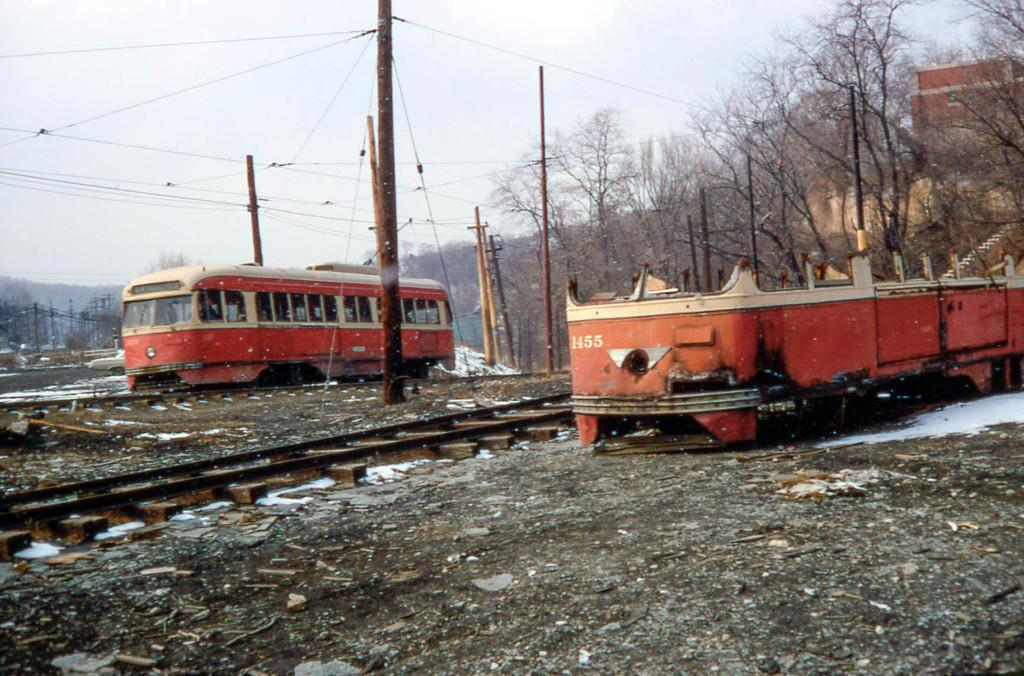What is the color scheme of the vehicle in the image? The vehicle in the image has red and cream colors. What structures can be seen in the image besides the vehicle? There are electric poles and trees visible in the image. What type of surface is the vehicle on? There are tracks visible in the image, suggesting that the vehicle is on a train track. What is the color of the sky in the background? The sky in the background appears to be white. What type of record can be seen spinning on the vehicle's roof in the image? There is no record present in the image; it only features a vehicle with red and cream colors, electric poles, trees, tracks, and a white sky in the background. 